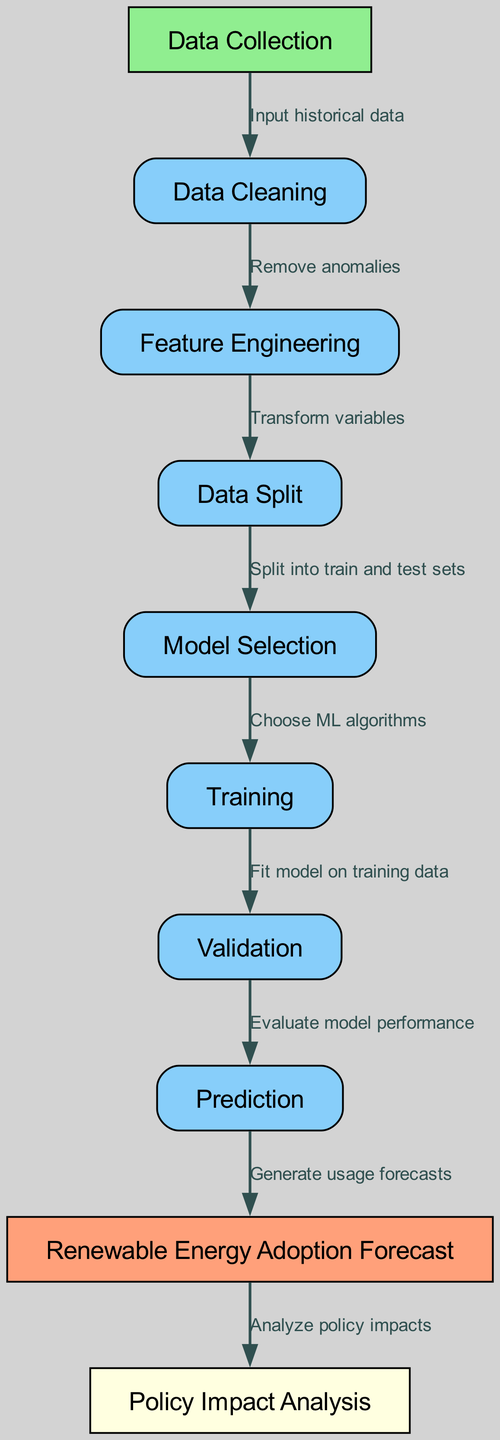What is the first step in the diagram? The first step in the diagram is labeled "Data Collection." It is the starting point from which various processes flow in the machine learning diagram.
Answer: Data Collection How many nodes are present in the diagram? The diagram consists of a total of ten nodes, each representing a different process in the machine learning workflow.
Answer: Ten What process directly follows Data Cleaning? The process that follows Data Cleaning is "Feature Engineering," demonstrated by the directed edge from node 2 to node 3.
Answer: Feature Engineering Which node is associated with Policy Impact Analysis? The node associated with Policy Impact Analysis is node 9. It receives input from the Renewable Energy Adoption Forecast process, indicating its position in the analysis after predictions have been made.
Answer: Policy Impact Analysis What is the label of the edge that connects Training to Validation? The label of the edge connecting the Training node to the Validation node is "Fit model on training data." This indicates the specific action taken in this step of the machine learning process.
Answer: Fit model on training data What is the final output of the diagram? The final output of the diagram is "Renewable Energy Adoption Forecast," which is the result produced after the prediction process. This is the ultimate goal of the entire workflow depicted in the diagram.
Answer: Renewable Energy Adoption Forecast Which step occurs before Model Selection? The step that occurs before Model Selection is "Data Split." This shows that the data needs to be divided into training and testing subsets prior to selecting the appropriate machine learning algorithms.
Answer: Data Split What is the relationship between Prediction and Policy Impact Analysis? The relationship is that Prediction leads to Policy Impact Analysis, indicating that forecasts generated for renewable energy usage are used to evaluate potential policy outcomes.
Answer: Leads to Which node includes the action of generating usage forecasts? The node that includes the action of generating usage forecasts is "Prediction," which serves as a key functional point where model outputs are utilized.
Answer: Prediction What is the purpose of Feature Engineering in this context? The purpose of Feature Engineering in this context is to transform variables, which is fundamental to ensure that the data is appropriately formatted and relevant for training the machine learning model.
Answer: Transform variables 